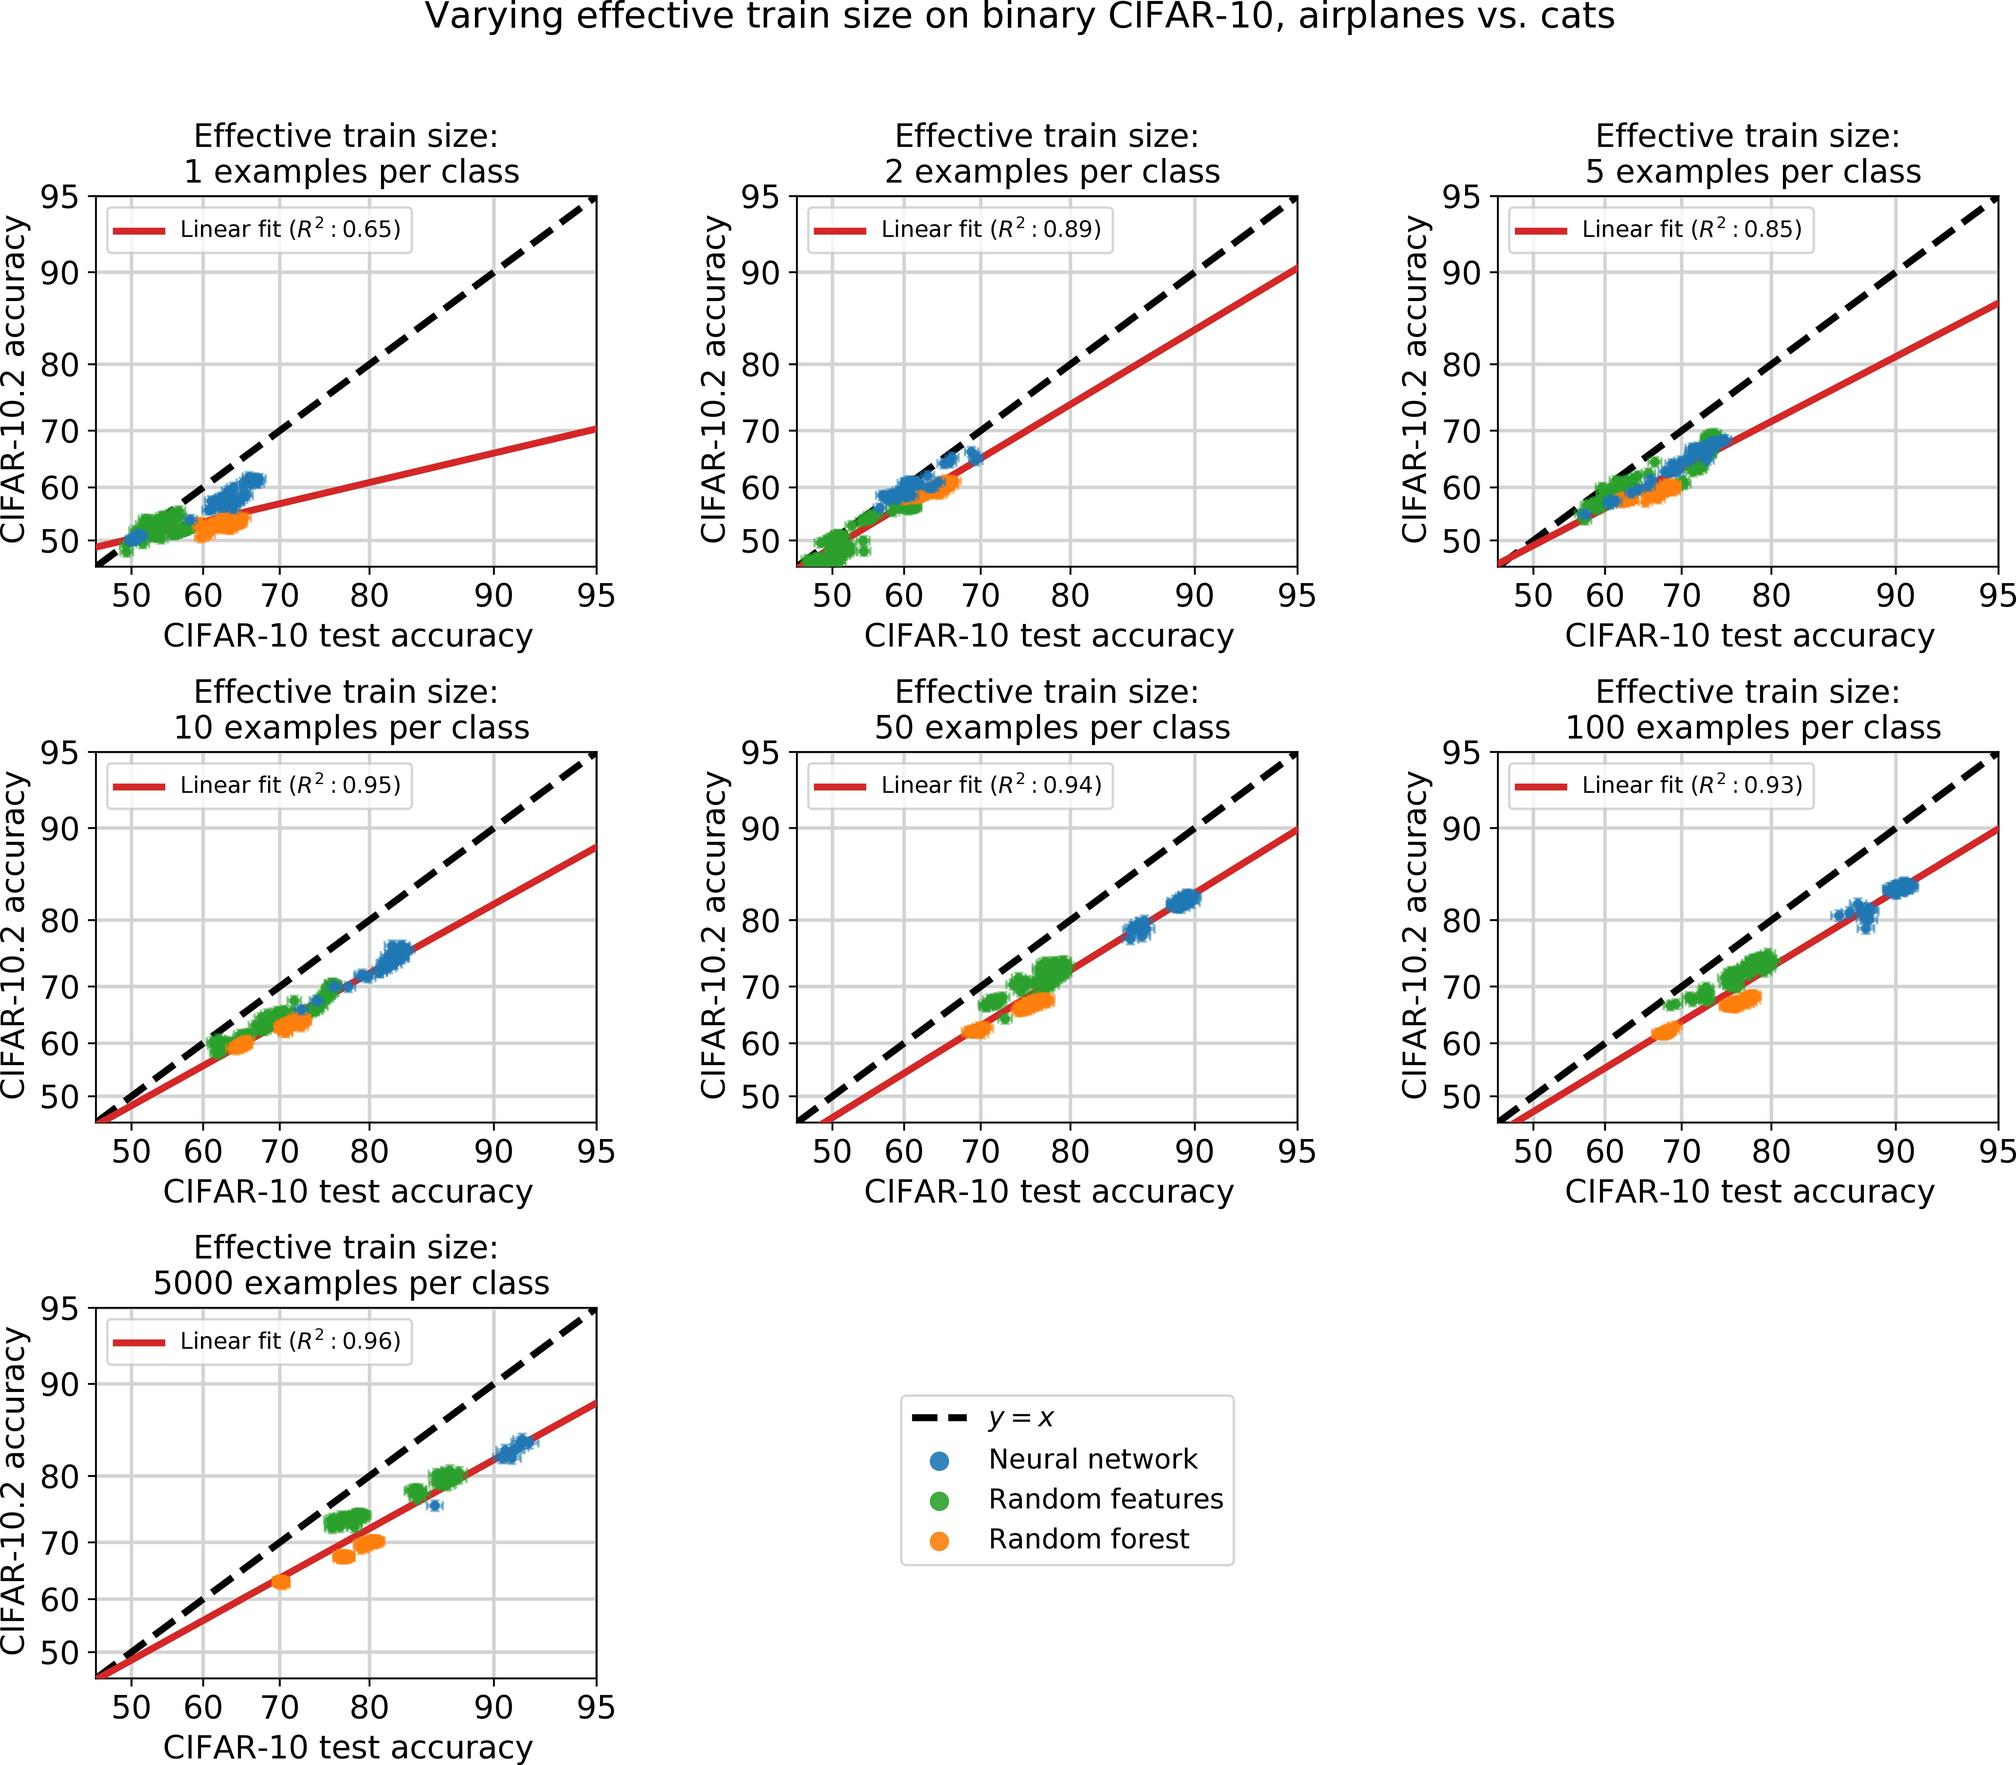Based on the graphs, what can be inferred about the relationship between CIFAR-10 test accuracy and the size of the training set? There is a negative correlation between training set size and test accuracy. Larger training set sizes tend to yield better test accuracy. Test accuracy is independent of the training set size. Test accuracy decreases as the number of examples per class increases beyond 50. The graphs consistently show an upward trend in CIFAR-10 test accuracy as the effective train size increases. This indicates that larger training set sizes are associated with better performance on the test set. Therefore, the correct answer is B. 